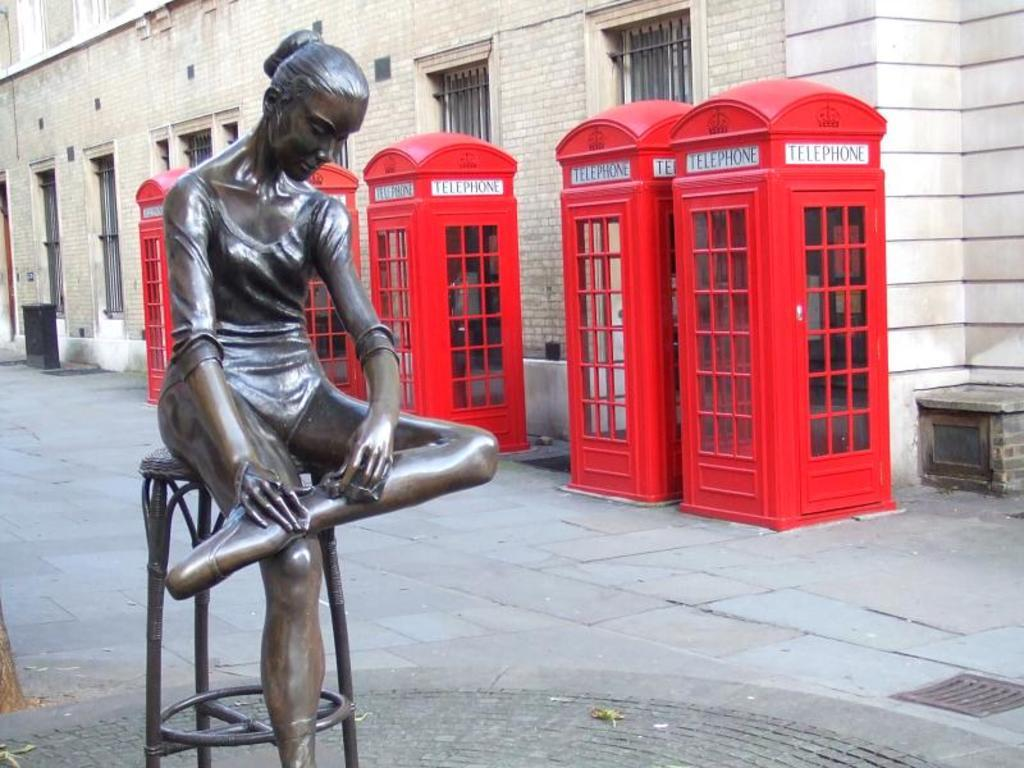What is the main subject in the image? There is a statue in the image. What other objects can be seen in the image? There are red color telephone booths and a building visible in the image. What architectural feature can be observed on the building? There are windows visible in the image. What type of button can be seen on the statue's clothing in the image? There is no button visible on the statue's clothing in the image. How does the statue rub its hands together in the image? The statue does not have the ability to rub its hands together, as it is a non-living object. 